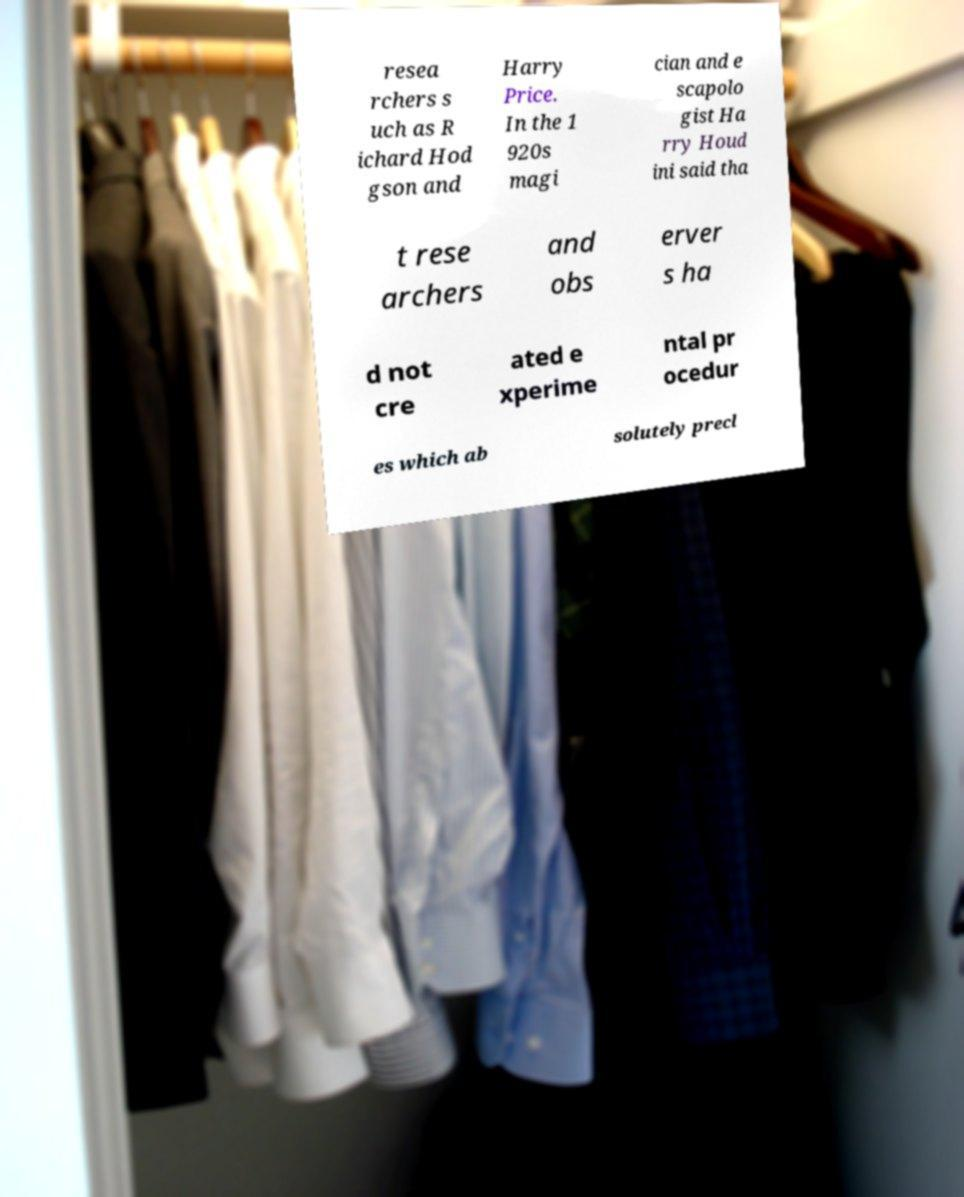Could you assist in decoding the text presented in this image and type it out clearly? resea rchers s uch as R ichard Hod gson and Harry Price. In the 1 920s magi cian and e scapolo gist Ha rry Houd ini said tha t rese archers and obs erver s ha d not cre ated e xperime ntal pr ocedur es which ab solutely precl 